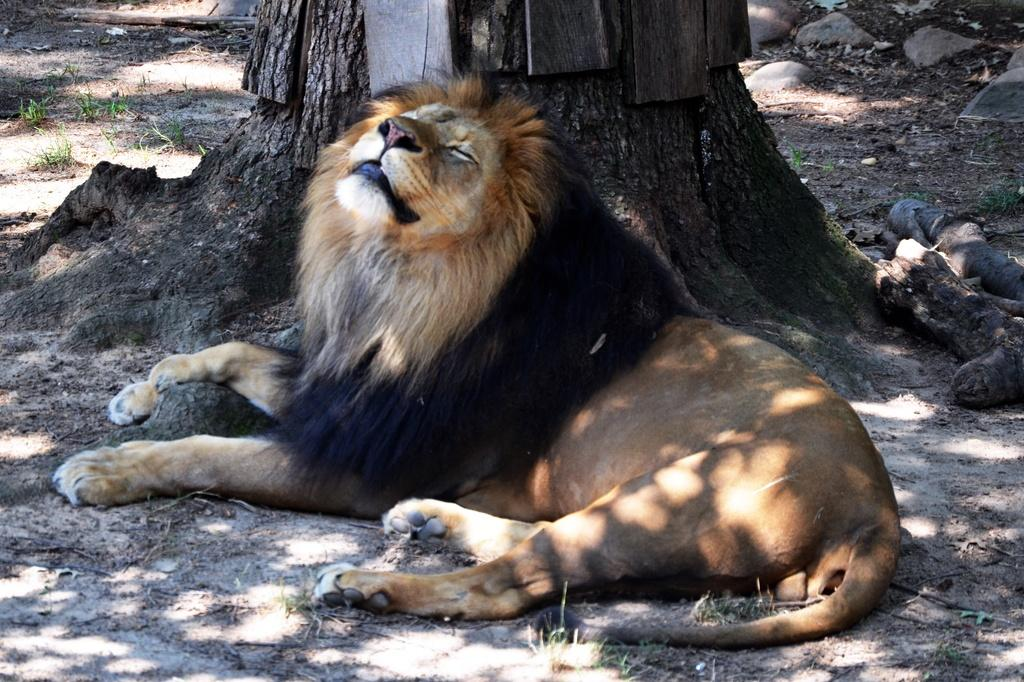What animal is the main subject of the image? There is a lion in the image. Where is the lion located in the image? The lion is on the ground. What can be seen in the background of the image? There is a tree, stones, and wooden logs in the background of the image. How many dogs are sitting next to the lion in the image? There are no dogs present in the image; it features a lion on the ground. What type of elbow is visible in the image? There is no elbow present in the image; it features a lion and background elements. 